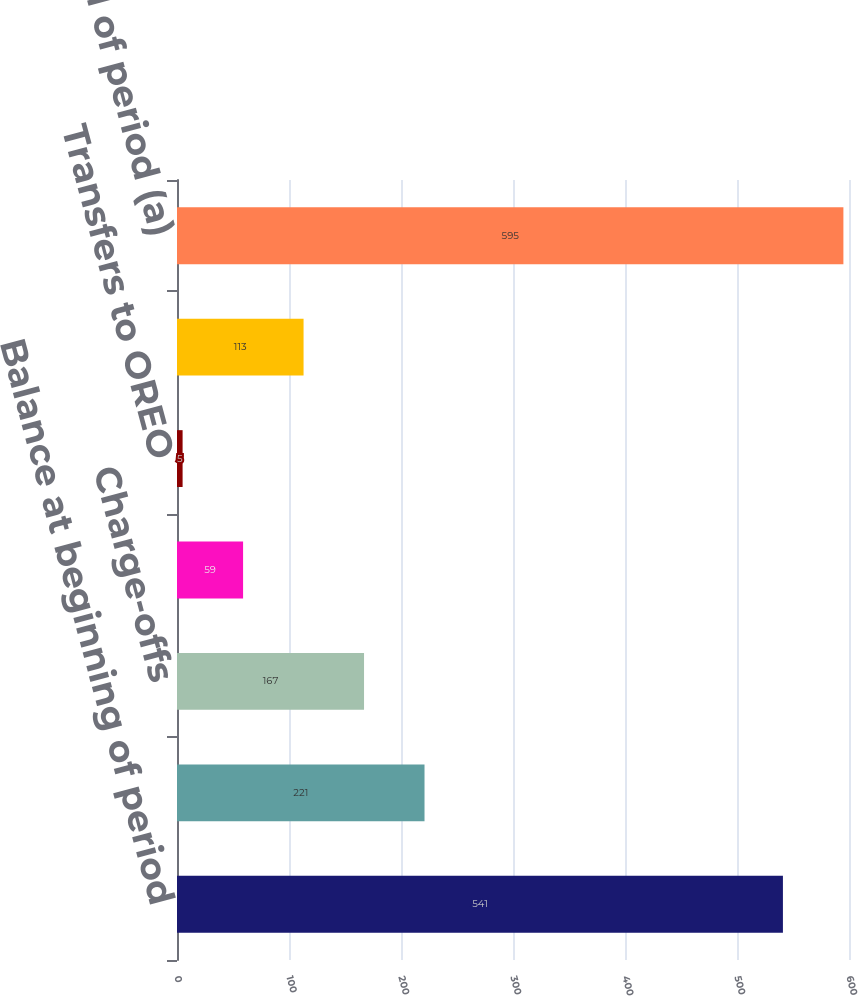Convert chart. <chart><loc_0><loc_0><loc_500><loc_500><bar_chart><fcel>Balance at beginning of period<fcel>Loans placed on nonaccrual<fcel>Charge-offs<fcel>Payments<fcel>Transfers to OREO<fcel>Loans returned to accrual<fcel>Balance at end of period (a)<nl><fcel>541<fcel>221<fcel>167<fcel>59<fcel>5<fcel>113<fcel>595<nl></chart> 